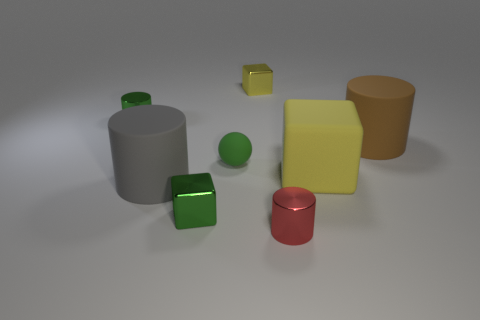Subtract 2 cylinders. How many cylinders are left? 2 Add 1 big purple shiny cylinders. How many objects exist? 9 Subtract all brown cylinders. How many cylinders are left? 3 Subtract all metallic blocks. How many blocks are left? 1 Subtract all cyan cylinders. Subtract all red cubes. How many cylinders are left? 4 Subtract all blocks. How many objects are left? 5 Subtract all gray rubber objects. Subtract all spheres. How many objects are left? 6 Add 4 tiny red metallic objects. How many tiny red metallic objects are left? 5 Add 3 gray matte objects. How many gray matte objects exist? 4 Subtract 1 brown cylinders. How many objects are left? 7 